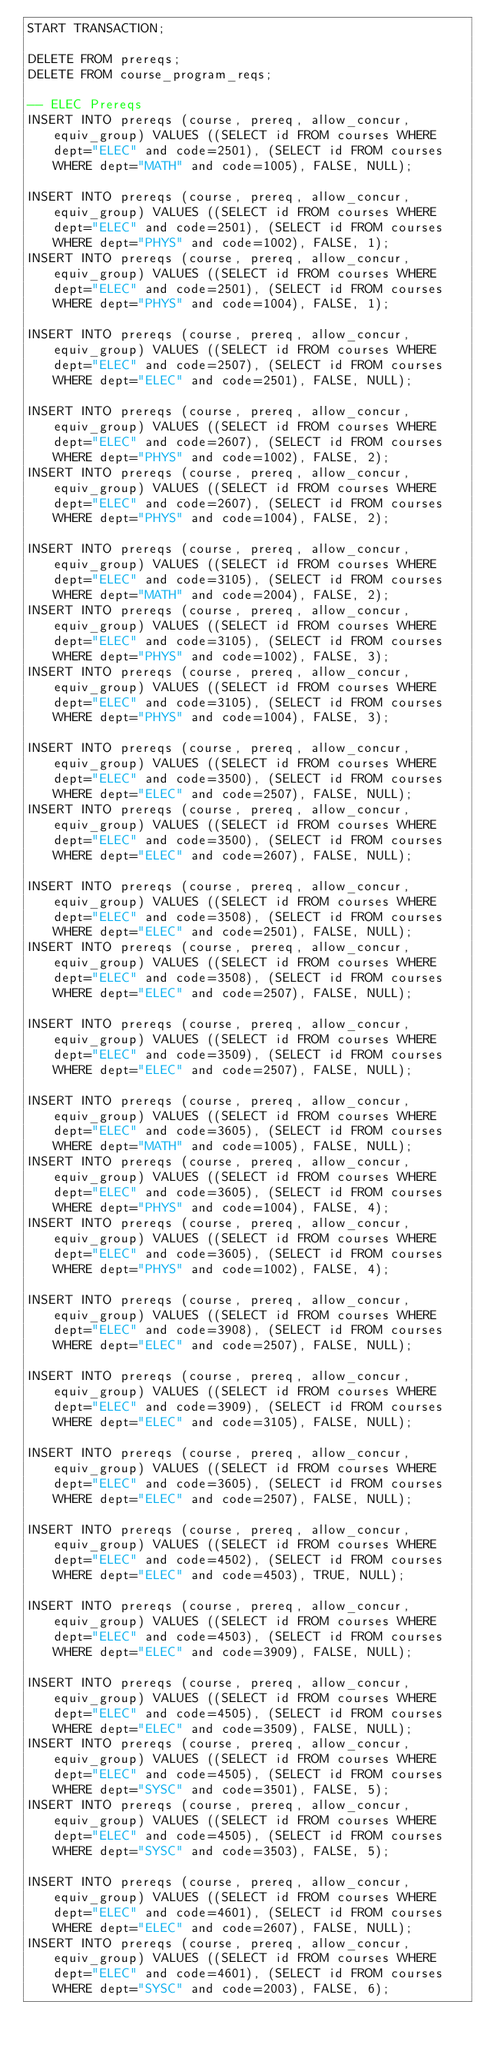<code> <loc_0><loc_0><loc_500><loc_500><_SQL_>START TRANSACTION;

DELETE FROM prereqs;
DELETE FROM course_program_reqs;

-- ELEC Prereqs
INSERT INTO prereqs (course, prereq, allow_concur, equiv_group) VALUES ((SELECT id FROM courses WHERE dept="ELEC" and code=2501), (SELECT id FROM courses WHERE dept="MATH" and code=1005), FALSE, NULL);

INSERT INTO prereqs (course, prereq, allow_concur, equiv_group) VALUES ((SELECT id FROM courses WHERE dept="ELEC" and code=2501), (SELECT id FROM courses WHERE dept="PHYS" and code=1002), FALSE, 1);
INSERT INTO prereqs (course, prereq, allow_concur, equiv_group) VALUES ((SELECT id FROM courses WHERE dept="ELEC" and code=2501), (SELECT id FROM courses WHERE dept="PHYS" and code=1004), FALSE, 1);

INSERT INTO prereqs (course, prereq, allow_concur, equiv_group) VALUES ((SELECT id FROM courses WHERE dept="ELEC" and code=2507), (SELECT id FROM courses WHERE dept="ELEC" and code=2501), FALSE, NULL);

INSERT INTO prereqs (course, prereq, allow_concur, equiv_group) VALUES ((SELECT id FROM courses WHERE dept="ELEC" and code=2607), (SELECT id FROM courses WHERE dept="PHYS" and code=1002), FALSE, 2);
INSERT INTO prereqs (course, prereq, allow_concur, equiv_group) VALUES ((SELECT id FROM courses WHERE dept="ELEC" and code=2607), (SELECT id FROM courses WHERE dept="PHYS" and code=1004), FALSE, 2);

INSERT INTO prereqs (course, prereq, allow_concur, equiv_group) VALUES ((SELECT id FROM courses WHERE dept="ELEC" and code=3105), (SELECT id FROM courses WHERE dept="MATH" and code=2004), FALSE, 2);
INSERT INTO prereqs (course, prereq, allow_concur, equiv_group) VALUES ((SELECT id FROM courses WHERE dept="ELEC" and code=3105), (SELECT id FROM courses WHERE dept="PHYS" and code=1002), FALSE, 3);
INSERT INTO prereqs (course, prereq, allow_concur, equiv_group) VALUES ((SELECT id FROM courses WHERE dept="ELEC" and code=3105), (SELECT id FROM courses WHERE dept="PHYS" and code=1004), FALSE, 3);

INSERT INTO prereqs (course, prereq, allow_concur, equiv_group) VALUES ((SELECT id FROM courses WHERE dept="ELEC" and code=3500), (SELECT id FROM courses WHERE dept="ELEC" and code=2507), FALSE, NULL);
INSERT INTO prereqs (course, prereq, allow_concur, equiv_group) VALUES ((SELECT id FROM courses WHERE dept="ELEC" and code=3500), (SELECT id FROM courses WHERE dept="ELEC" and code=2607), FALSE, NULL);

INSERT INTO prereqs (course, prereq, allow_concur, equiv_group) VALUES ((SELECT id FROM courses WHERE dept="ELEC" and code=3508), (SELECT id FROM courses WHERE dept="ELEC" and code=2501), FALSE, NULL);
INSERT INTO prereqs (course, prereq, allow_concur, equiv_group) VALUES ((SELECT id FROM courses WHERE dept="ELEC" and code=3508), (SELECT id FROM courses WHERE dept="ELEC" and code=2507), FALSE, NULL);

INSERT INTO prereqs (course, prereq, allow_concur, equiv_group) VALUES ((SELECT id FROM courses WHERE dept="ELEC" and code=3509), (SELECT id FROM courses WHERE dept="ELEC" and code=2507), FALSE, NULL);

INSERT INTO prereqs (course, prereq, allow_concur, equiv_group) VALUES ((SELECT id FROM courses WHERE dept="ELEC" and code=3605), (SELECT id FROM courses WHERE dept="MATH" and code=1005), FALSE, NULL);
INSERT INTO prereqs (course, prereq, allow_concur, equiv_group) VALUES ((SELECT id FROM courses WHERE dept="ELEC" and code=3605), (SELECT id FROM courses WHERE dept="PHYS" and code=1004), FALSE, 4);
INSERT INTO prereqs (course, prereq, allow_concur, equiv_group) VALUES ((SELECT id FROM courses WHERE dept="ELEC" and code=3605), (SELECT id FROM courses WHERE dept="PHYS" and code=1002), FALSE, 4);

INSERT INTO prereqs (course, prereq, allow_concur, equiv_group) VALUES ((SELECT id FROM courses WHERE dept="ELEC" and code=3908), (SELECT id FROM courses WHERE dept="ELEC" and code=2507), FALSE, NULL);

INSERT INTO prereqs (course, prereq, allow_concur, equiv_group) VALUES ((SELECT id FROM courses WHERE dept="ELEC" and code=3909), (SELECT id FROM courses WHERE dept="ELEC" and code=3105), FALSE, NULL);

INSERT INTO prereqs (course, prereq, allow_concur, equiv_group) VALUES ((SELECT id FROM courses WHERE dept="ELEC" and code=3605), (SELECT id FROM courses WHERE dept="ELEC" and code=2507), FALSE, NULL);

INSERT INTO prereqs (course, prereq, allow_concur, equiv_group) VALUES ((SELECT id FROM courses WHERE dept="ELEC" and code=4502), (SELECT id FROM courses WHERE dept="ELEC" and code=4503), TRUE, NULL);

INSERT INTO prereqs (course, prereq, allow_concur, equiv_group) VALUES ((SELECT id FROM courses WHERE dept="ELEC" and code=4503), (SELECT id FROM courses WHERE dept="ELEC" and code=3909), FALSE, NULL);

INSERT INTO prereqs (course, prereq, allow_concur, equiv_group) VALUES ((SELECT id FROM courses WHERE dept="ELEC" and code=4505), (SELECT id FROM courses WHERE dept="ELEC" and code=3509), FALSE, NULL);
INSERT INTO prereqs (course, prereq, allow_concur, equiv_group) VALUES ((SELECT id FROM courses WHERE dept="ELEC" and code=4505), (SELECT id FROM courses WHERE dept="SYSC" and code=3501), FALSE, 5);
INSERT INTO prereqs (course, prereq, allow_concur, equiv_group) VALUES ((SELECT id FROM courses WHERE dept="ELEC" and code=4505), (SELECT id FROM courses WHERE dept="SYSC" and code=3503), FALSE, 5);

INSERT INTO prereqs (course, prereq, allow_concur, equiv_group) VALUES ((SELECT id FROM courses WHERE dept="ELEC" and code=4601), (SELECT id FROM courses WHERE dept="ELEC" and code=2607), FALSE, NULL);
INSERT INTO prereqs (course, prereq, allow_concur, equiv_group) VALUES ((SELECT id FROM courses WHERE dept="ELEC" and code=4601), (SELECT id FROM courses WHERE dept="SYSC" and code=2003), FALSE, 6);</code> 